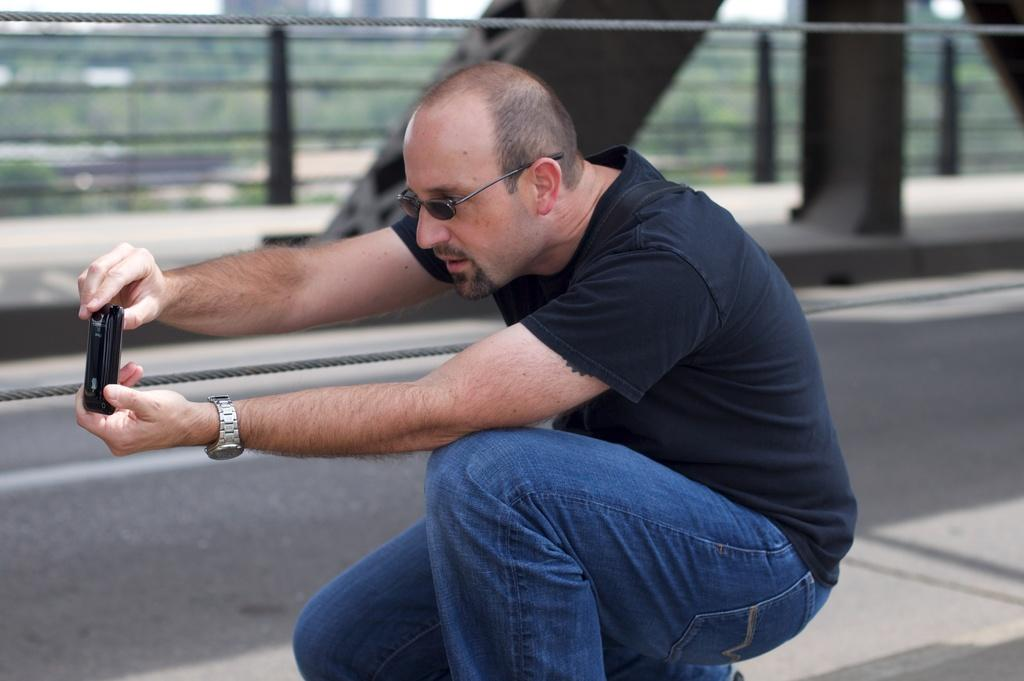What is the person in the image holding? The person in the image is holding a camera. What can be seen in the foreground of the image? There is a road and a wall in the image. What object is visible that might be used for tying or securing? There is a rope visible in the image. How would you describe the background of the image? The background appears blurry. What type of animal is causing the person pain in the image? There is no animal present in the image, nor is there any indication of pain. 